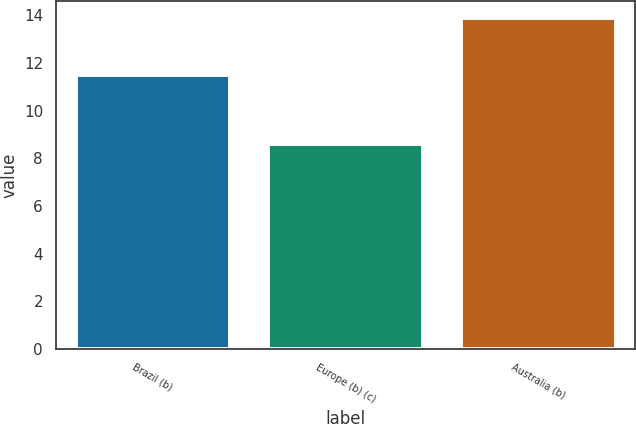<chart> <loc_0><loc_0><loc_500><loc_500><bar_chart><fcel>Brazil (b)<fcel>Europe (b) (c)<fcel>Australia (b)<nl><fcel>11.5<fcel>8.6<fcel>13.9<nl></chart> 